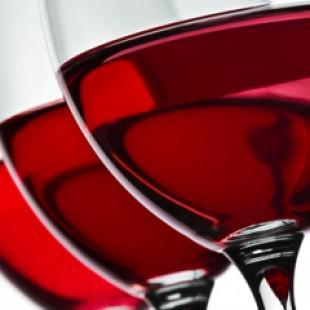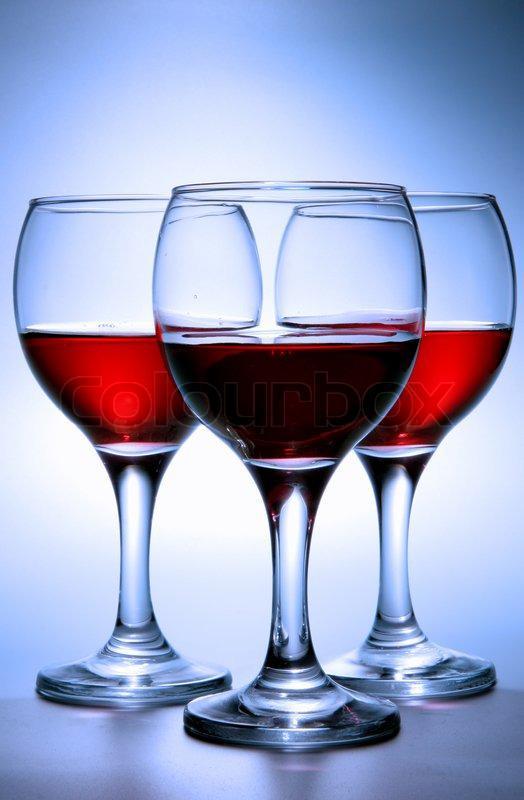The first image is the image on the left, the second image is the image on the right. Examine the images to the left and right. Is the description "An image includes at least one bottle with a burgundy colored label and wrap over the cap." accurate? Answer yes or no. No. The first image is the image on the left, the second image is the image on the right. Examine the images to the left and right. Is the description "Three wine glasses are lined up in the image on the left." accurate? Answer yes or no. Yes. 